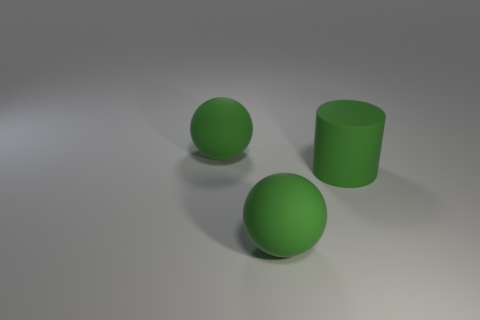There is a large cylinder; how many rubber balls are right of it?
Your answer should be compact. 0. The rubber cylinder is what color?
Your response must be concise. Green. What number of large objects are either rubber objects or cylinders?
Offer a terse response. 3. There is a object that is behind the green matte cylinder; is it the same color as the matte object that is in front of the large green rubber cylinder?
Provide a succinct answer. Yes. How many other things are there of the same color as the cylinder?
Provide a short and direct response. 2. The large matte thing that is behind the green cylinder has what shape?
Your answer should be very brief. Sphere. Is the number of green rubber things less than the number of tiny cyan cylinders?
Offer a terse response. No. Is the large sphere that is behind the big green rubber cylinder made of the same material as the large green cylinder?
Ensure brevity in your answer.  Yes. Is there any other thing that has the same size as the cylinder?
Give a very brief answer. Yes. Are there any green matte objects in front of the large cylinder?
Your response must be concise. Yes. 